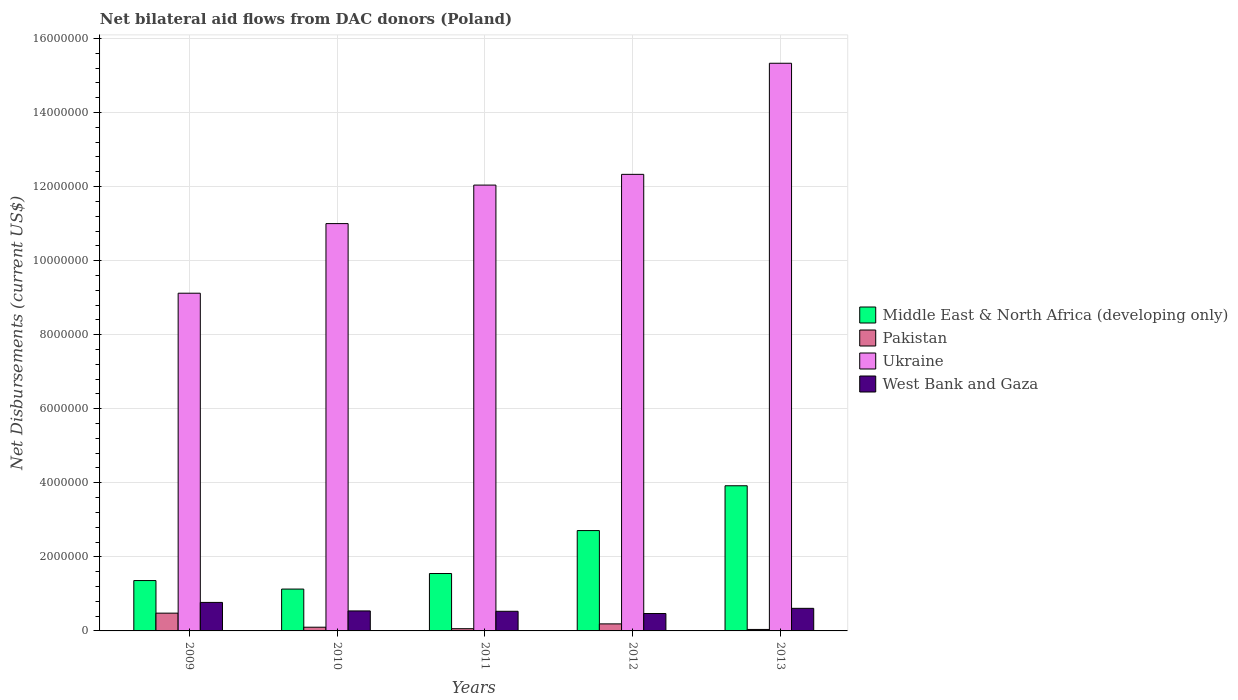Are the number of bars per tick equal to the number of legend labels?
Ensure brevity in your answer.  Yes. How many bars are there on the 1st tick from the left?
Offer a very short reply. 4. What is the net bilateral aid flows in Middle East & North Africa (developing only) in 2012?
Your answer should be very brief. 2.71e+06. Across all years, what is the maximum net bilateral aid flows in Ukraine?
Your response must be concise. 1.53e+07. Across all years, what is the minimum net bilateral aid flows in Ukraine?
Provide a short and direct response. 9.12e+06. What is the total net bilateral aid flows in Middle East & North Africa (developing only) in the graph?
Your answer should be very brief. 1.07e+07. What is the difference between the net bilateral aid flows in West Bank and Gaza in 2011 and that in 2012?
Give a very brief answer. 6.00e+04. What is the difference between the net bilateral aid flows in Middle East & North Africa (developing only) in 2009 and the net bilateral aid flows in Pakistan in 2012?
Give a very brief answer. 1.17e+06. What is the average net bilateral aid flows in Pakistan per year?
Your response must be concise. 1.74e+05. In the year 2009, what is the difference between the net bilateral aid flows in Middle East & North Africa (developing only) and net bilateral aid flows in Pakistan?
Keep it short and to the point. 8.80e+05. In how many years, is the net bilateral aid flows in Pakistan greater than 2000000 US$?
Offer a terse response. 0. What is the ratio of the net bilateral aid flows in West Bank and Gaza in 2010 to that in 2011?
Your answer should be compact. 1.02. Is the net bilateral aid flows in Middle East & North Africa (developing only) in 2011 less than that in 2013?
Offer a terse response. Yes. Is the difference between the net bilateral aid flows in Middle East & North Africa (developing only) in 2009 and 2013 greater than the difference between the net bilateral aid flows in Pakistan in 2009 and 2013?
Provide a short and direct response. No. What is the difference between the highest and the second highest net bilateral aid flows in West Bank and Gaza?
Provide a short and direct response. 1.60e+05. What is the difference between the highest and the lowest net bilateral aid flows in Ukraine?
Ensure brevity in your answer.  6.21e+06. In how many years, is the net bilateral aid flows in Ukraine greater than the average net bilateral aid flows in Ukraine taken over all years?
Make the answer very short. 3. Is the sum of the net bilateral aid flows in Middle East & North Africa (developing only) in 2010 and 2012 greater than the maximum net bilateral aid flows in West Bank and Gaza across all years?
Make the answer very short. Yes. Is it the case that in every year, the sum of the net bilateral aid flows in Middle East & North Africa (developing only) and net bilateral aid flows in West Bank and Gaza is greater than the sum of net bilateral aid flows in Pakistan and net bilateral aid flows in Ukraine?
Your answer should be compact. Yes. What does the 1st bar from the left in 2012 represents?
Your response must be concise. Middle East & North Africa (developing only). Is it the case that in every year, the sum of the net bilateral aid flows in West Bank and Gaza and net bilateral aid flows in Ukraine is greater than the net bilateral aid flows in Middle East & North Africa (developing only)?
Make the answer very short. Yes. How many bars are there?
Provide a short and direct response. 20. Are all the bars in the graph horizontal?
Give a very brief answer. No. Are the values on the major ticks of Y-axis written in scientific E-notation?
Ensure brevity in your answer.  No. What is the title of the graph?
Offer a very short reply. Net bilateral aid flows from DAC donors (Poland). What is the label or title of the Y-axis?
Keep it short and to the point. Net Disbursements (current US$). What is the Net Disbursements (current US$) in Middle East & North Africa (developing only) in 2009?
Your answer should be very brief. 1.36e+06. What is the Net Disbursements (current US$) of Pakistan in 2009?
Offer a terse response. 4.80e+05. What is the Net Disbursements (current US$) of Ukraine in 2009?
Your answer should be compact. 9.12e+06. What is the Net Disbursements (current US$) in West Bank and Gaza in 2009?
Make the answer very short. 7.70e+05. What is the Net Disbursements (current US$) in Middle East & North Africa (developing only) in 2010?
Your answer should be compact. 1.13e+06. What is the Net Disbursements (current US$) of Pakistan in 2010?
Provide a succinct answer. 1.00e+05. What is the Net Disbursements (current US$) in Ukraine in 2010?
Your answer should be compact. 1.10e+07. What is the Net Disbursements (current US$) of West Bank and Gaza in 2010?
Your answer should be very brief. 5.40e+05. What is the Net Disbursements (current US$) of Middle East & North Africa (developing only) in 2011?
Ensure brevity in your answer.  1.55e+06. What is the Net Disbursements (current US$) in Pakistan in 2011?
Make the answer very short. 6.00e+04. What is the Net Disbursements (current US$) in Ukraine in 2011?
Keep it short and to the point. 1.20e+07. What is the Net Disbursements (current US$) of West Bank and Gaza in 2011?
Keep it short and to the point. 5.30e+05. What is the Net Disbursements (current US$) in Middle East & North Africa (developing only) in 2012?
Give a very brief answer. 2.71e+06. What is the Net Disbursements (current US$) of Ukraine in 2012?
Your response must be concise. 1.23e+07. What is the Net Disbursements (current US$) of Middle East & North Africa (developing only) in 2013?
Your response must be concise. 3.92e+06. What is the Net Disbursements (current US$) of Pakistan in 2013?
Your response must be concise. 4.00e+04. What is the Net Disbursements (current US$) of Ukraine in 2013?
Provide a short and direct response. 1.53e+07. Across all years, what is the maximum Net Disbursements (current US$) of Middle East & North Africa (developing only)?
Your answer should be compact. 3.92e+06. Across all years, what is the maximum Net Disbursements (current US$) in Pakistan?
Offer a very short reply. 4.80e+05. Across all years, what is the maximum Net Disbursements (current US$) in Ukraine?
Give a very brief answer. 1.53e+07. Across all years, what is the maximum Net Disbursements (current US$) of West Bank and Gaza?
Keep it short and to the point. 7.70e+05. Across all years, what is the minimum Net Disbursements (current US$) in Middle East & North Africa (developing only)?
Make the answer very short. 1.13e+06. Across all years, what is the minimum Net Disbursements (current US$) of Pakistan?
Your response must be concise. 4.00e+04. Across all years, what is the minimum Net Disbursements (current US$) in Ukraine?
Your answer should be compact. 9.12e+06. What is the total Net Disbursements (current US$) in Middle East & North Africa (developing only) in the graph?
Ensure brevity in your answer.  1.07e+07. What is the total Net Disbursements (current US$) of Pakistan in the graph?
Give a very brief answer. 8.70e+05. What is the total Net Disbursements (current US$) in Ukraine in the graph?
Your answer should be compact. 5.98e+07. What is the total Net Disbursements (current US$) in West Bank and Gaza in the graph?
Offer a very short reply. 2.92e+06. What is the difference between the Net Disbursements (current US$) of Pakistan in 2009 and that in 2010?
Ensure brevity in your answer.  3.80e+05. What is the difference between the Net Disbursements (current US$) of Ukraine in 2009 and that in 2010?
Offer a terse response. -1.88e+06. What is the difference between the Net Disbursements (current US$) of Middle East & North Africa (developing only) in 2009 and that in 2011?
Your response must be concise. -1.90e+05. What is the difference between the Net Disbursements (current US$) in Pakistan in 2009 and that in 2011?
Your answer should be very brief. 4.20e+05. What is the difference between the Net Disbursements (current US$) in Ukraine in 2009 and that in 2011?
Offer a terse response. -2.92e+06. What is the difference between the Net Disbursements (current US$) of Middle East & North Africa (developing only) in 2009 and that in 2012?
Your answer should be compact. -1.35e+06. What is the difference between the Net Disbursements (current US$) of Pakistan in 2009 and that in 2012?
Offer a very short reply. 2.90e+05. What is the difference between the Net Disbursements (current US$) in Ukraine in 2009 and that in 2012?
Offer a terse response. -3.21e+06. What is the difference between the Net Disbursements (current US$) of Middle East & North Africa (developing only) in 2009 and that in 2013?
Keep it short and to the point. -2.56e+06. What is the difference between the Net Disbursements (current US$) in Pakistan in 2009 and that in 2013?
Your answer should be very brief. 4.40e+05. What is the difference between the Net Disbursements (current US$) of Ukraine in 2009 and that in 2013?
Offer a terse response. -6.21e+06. What is the difference between the Net Disbursements (current US$) in West Bank and Gaza in 2009 and that in 2013?
Give a very brief answer. 1.60e+05. What is the difference between the Net Disbursements (current US$) of Middle East & North Africa (developing only) in 2010 and that in 2011?
Provide a short and direct response. -4.20e+05. What is the difference between the Net Disbursements (current US$) of Pakistan in 2010 and that in 2011?
Ensure brevity in your answer.  4.00e+04. What is the difference between the Net Disbursements (current US$) of Ukraine in 2010 and that in 2011?
Your response must be concise. -1.04e+06. What is the difference between the Net Disbursements (current US$) of West Bank and Gaza in 2010 and that in 2011?
Offer a very short reply. 10000. What is the difference between the Net Disbursements (current US$) of Middle East & North Africa (developing only) in 2010 and that in 2012?
Give a very brief answer. -1.58e+06. What is the difference between the Net Disbursements (current US$) of Ukraine in 2010 and that in 2012?
Offer a terse response. -1.33e+06. What is the difference between the Net Disbursements (current US$) in West Bank and Gaza in 2010 and that in 2012?
Provide a succinct answer. 7.00e+04. What is the difference between the Net Disbursements (current US$) in Middle East & North Africa (developing only) in 2010 and that in 2013?
Give a very brief answer. -2.79e+06. What is the difference between the Net Disbursements (current US$) of Ukraine in 2010 and that in 2013?
Offer a terse response. -4.33e+06. What is the difference between the Net Disbursements (current US$) of West Bank and Gaza in 2010 and that in 2013?
Keep it short and to the point. -7.00e+04. What is the difference between the Net Disbursements (current US$) of Middle East & North Africa (developing only) in 2011 and that in 2012?
Your answer should be compact. -1.16e+06. What is the difference between the Net Disbursements (current US$) of West Bank and Gaza in 2011 and that in 2012?
Provide a succinct answer. 6.00e+04. What is the difference between the Net Disbursements (current US$) in Middle East & North Africa (developing only) in 2011 and that in 2013?
Offer a very short reply. -2.37e+06. What is the difference between the Net Disbursements (current US$) in Ukraine in 2011 and that in 2013?
Ensure brevity in your answer.  -3.29e+06. What is the difference between the Net Disbursements (current US$) of West Bank and Gaza in 2011 and that in 2013?
Offer a terse response. -8.00e+04. What is the difference between the Net Disbursements (current US$) in Middle East & North Africa (developing only) in 2012 and that in 2013?
Your response must be concise. -1.21e+06. What is the difference between the Net Disbursements (current US$) of Ukraine in 2012 and that in 2013?
Give a very brief answer. -3.00e+06. What is the difference between the Net Disbursements (current US$) of Middle East & North Africa (developing only) in 2009 and the Net Disbursements (current US$) of Pakistan in 2010?
Provide a short and direct response. 1.26e+06. What is the difference between the Net Disbursements (current US$) of Middle East & North Africa (developing only) in 2009 and the Net Disbursements (current US$) of Ukraine in 2010?
Provide a succinct answer. -9.64e+06. What is the difference between the Net Disbursements (current US$) in Middle East & North Africa (developing only) in 2009 and the Net Disbursements (current US$) in West Bank and Gaza in 2010?
Ensure brevity in your answer.  8.20e+05. What is the difference between the Net Disbursements (current US$) in Pakistan in 2009 and the Net Disbursements (current US$) in Ukraine in 2010?
Offer a very short reply. -1.05e+07. What is the difference between the Net Disbursements (current US$) of Ukraine in 2009 and the Net Disbursements (current US$) of West Bank and Gaza in 2010?
Your answer should be compact. 8.58e+06. What is the difference between the Net Disbursements (current US$) in Middle East & North Africa (developing only) in 2009 and the Net Disbursements (current US$) in Pakistan in 2011?
Offer a terse response. 1.30e+06. What is the difference between the Net Disbursements (current US$) of Middle East & North Africa (developing only) in 2009 and the Net Disbursements (current US$) of Ukraine in 2011?
Your answer should be very brief. -1.07e+07. What is the difference between the Net Disbursements (current US$) in Middle East & North Africa (developing only) in 2009 and the Net Disbursements (current US$) in West Bank and Gaza in 2011?
Keep it short and to the point. 8.30e+05. What is the difference between the Net Disbursements (current US$) in Pakistan in 2009 and the Net Disbursements (current US$) in Ukraine in 2011?
Make the answer very short. -1.16e+07. What is the difference between the Net Disbursements (current US$) of Pakistan in 2009 and the Net Disbursements (current US$) of West Bank and Gaza in 2011?
Your answer should be very brief. -5.00e+04. What is the difference between the Net Disbursements (current US$) of Ukraine in 2009 and the Net Disbursements (current US$) of West Bank and Gaza in 2011?
Your answer should be very brief. 8.59e+06. What is the difference between the Net Disbursements (current US$) in Middle East & North Africa (developing only) in 2009 and the Net Disbursements (current US$) in Pakistan in 2012?
Ensure brevity in your answer.  1.17e+06. What is the difference between the Net Disbursements (current US$) in Middle East & North Africa (developing only) in 2009 and the Net Disbursements (current US$) in Ukraine in 2012?
Offer a very short reply. -1.10e+07. What is the difference between the Net Disbursements (current US$) in Middle East & North Africa (developing only) in 2009 and the Net Disbursements (current US$) in West Bank and Gaza in 2012?
Provide a short and direct response. 8.90e+05. What is the difference between the Net Disbursements (current US$) of Pakistan in 2009 and the Net Disbursements (current US$) of Ukraine in 2012?
Offer a terse response. -1.18e+07. What is the difference between the Net Disbursements (current US$) of Pakistan in 2009 and the Net Disbursements (current US$) of West Bank and Gaza in 2012?
Your answer should be very brief. 10000. What is the difference between the Net Disbursements (current US$) in Ukraine in 2009 and the Net Disbursements (current US$) in West Bank and Gaza in 2012?
Keep it short and to the point. 8.65e+06. What is the difference between the Net Disbursements (current US$) in Middle East & North Africa (developing only) in 2009 and the Net Disbursements (current US$) in Pakistan in 2013?
Your answer should be very brief. 1.32e+06. What is the difference between the Net Disbursements (current US$) in Middle East & North Africa (developing only) in 2009 and the Net Disbursements (current US$) in Ukraine in 2013?
Offer a very short reply. -1.40e+07. What is the difference between the Net Disbursements (current US$) of Middle East & North Africa (developing only) in 2009 and the Net Disbursements (current US$) of West Bank and Gaza in 2013?
Give a very brief answer. 7.50e+05. What is the difference between the Net Disbursements (current US$) in Pakistan in 2009 and the Net Disbursements (current US$) in Ukraine in 2013?
Provide a succinct answer. -1.48e+07. What is the difference between the Net Disbursements (current US$) of Ukraine in 2009 and the Net Disbursements (current US$) of West Bank and Gaza in 2013?
Provide a short and direct response. 8.51e+06. What is the difference between the Net Disbursements (current US$) of Middle East & North Africa (developing only) in 2010 and the Net Disbursements (current US$) of Pakistan in 2011?
Your answer should be very brief. 1.07e+06. What is the difference between the Net Disbursements (current US$) of Middle East & North Africa (developing only) in 2010 and the Net Disbursements (current US$) of Ukraine in 2011?
Provide a short and direct response. -1.09e+07. What is the difference between the Net Disbursements (current US$) of Pakistan in 2010 and the Net Disbursements (current US$) of Ukraine in 2011?
Provide a succinct answer. -1.19e+07. What is the difference between the Net Disbursements (current US$) of Pakistan in 2010 and the Net Disbursements (current US$) of West Bank and Gaza in 2011?
Give a very brief answer. -4.30e+05. What is the difference between the Net Disbursements (current US$) in Ukraine in 2010 and the Net Disbursements (current US$) in West Bank and Gaza in 2011?
Provide a short and direct response. 1.05e+07. What is the difference between the Net Disbursements (current US$) of Middle East & North Africa (developing only) in 2010 and the Net Disbursements (current US$) of Pakistan in 2012?
Give a very brief answer. 9.40e+05. What is the difference between the Net Disbursements (current US$) in Middle East & North Africa (developing only) in 2010 and the Net Disbursements (current US$) in Ukraine in 2012?
Your answer should be very brief. -1.12e+07. What is the difference between the Net Disbursements (current US$) of Pakistan in 2010 and the Net Disbursements (current US$) of Ukraine in 2012?
Keep it short and to the point. -1.22e+07. What is the difference between the Net Disbursements (current US$) of Pakistan in 2010 and the Net Disbursements (current US$) of West Bank and Gaza in 2012?
Ensure brevity in your answer.  -3.70e+05. What is the difference between the Net Disbursements (current US$) in Ukraine in 2010 and the Net Disbursements (current US$) in West Bank and Gaza in 2012?
Offer a terse response. 1.05e+07. What is the difference between the Net Disbursements (current US$) in Middle East & North Africa (developing only) in 2010 and the Net Disbursements (current US$) in Pakistan in 2013?
Keep it short and to the point. 1.09e+06. What is the difference between the Net Disbursements (current US$) in Middle East & North Africa (developing only) in 2010 and the Net Disbursements (current US$) in Ukraine in 2013?
Make the answer very short. -1.42e+07. What is the difference between the Net Disbursements (current US$) in Middle East & North Africa (developing only) in 2010 and the Net Disbursements (current US$) in West Bank and Gaza in 2013?
Keep it short and to the point. 5.20e+05. What is the difference between the Net Disbursements (current US$) in Pakistan in 2010 and the Net Disbursements (current US$) in Ukraine in 2013?
Ensure brevity in your answer.  -1.52e+07. What is the difference between the Net Disbursements (current US$) of Pakistan in 2010 and the Net Disbursements (current US$) of West Bank and Gaza in 2013?
Your answer should be compact. -5.10e+05. What is the difference between the Net Disbursements (current US$) of Ukraine in 2010 and the Net Disbursements (current US$) of West Bank and Gaza in 2013?
Give a very brief answer. 1.04e+07. What is the difference between the Net Disbursements (current US$) in Middle East & North Africa (developing only) in 2011 and the Net Disbursements (current US$) in Pakistan in 2012?
Provide a short and direct response. 1.36e+06. What is the difference between the Net Disbursements (current US$) of Middle East & North Africa (developing only) in 2011 and the Net Disbursements (current US$) of Ukraine in 2012?
Offer a very short reply. -1.08e+07. What is the difference between the Net Disbursements (current US$) of Middle East & North Africa (developing only) in 2011 and the Net Disbursements (current US$) of West Bank and Gaza in 2012?
Keep it short and to the point. 1.08e+06. What is the difference between the Net Disbursements (current US$) in Pakistan in 2011 and the Net Disbursements (current US$) in Ukraine in 2012?
Make the answer very short. -1.23e+07. What is the difference between the Net Disbursements (current US$) in Pakistan in 2011 and the Net Disbursements (current US$) in West Bank and Gaza in 2012?
Keep it short and to the point. -4.10e+05. What is the difference between the Net Disbursements (current US$) of Ukraine in 2011 and the Net Disbursements (current US$) of West Bank and Gaza in 2012?
Ensure brevity in your answer.  1.16e+07. What is the difference between the Net Disbursements (current US$) in Middle East & North Africa (developing only) in 2011 and the Net Disbursements (current US$) in Pakistan in 2013?
Keep it short and to the point. 1.51e+06. What is the difference between the Net Disbursements (current US$) in Middle East & North Africa (developing only) in 2011 and the Net Disbursements (current US$) in Ukraine in 2013?
Offer a terse response. -1.38e+07. What is the difference between the Net Disbursements (current US$) in Middle East & North Africa (developing only) in 2011 and the Net Disbursements (current US$) in West Bank and Gaza in 2013?
Provide a succinct answer. 9.40e+05. What is the difference between the Net Disbursements (current US$) of Pakistan in 2011 and the Net Disbursements (current US$) of Ukraine in 2013?
Keep it short and to the point. -1.53e+07. What is the difference between the Net Disbursements (current US$) in Pakistan in 2011 and the Net Disbursements (current US$) in West Bank and Gaza in 2013?
Ensure brevity in your answer.  -5.50e+05. What is the difference between the Net Disbursements (current US$) of Ukraine in 2011 and the Net Disbursements (current US$) of West Bank and Gaza in 2013?
Make the answer very short. 1.14e+07. What is the difference between the Net Disbursements (current US$) in Middle East & North Africa (developing only) in 2012 and the Net Disbursements (current US$) in Pakistan in 2013?
Keep it short and to the point. 2.67e+06. What is the difference between the Net Disbursements (current US$) of Middle East & North Africa (developing only) in 2012 and the Net Disbursements (current US$) of Ukraine in 2013?
Offer a very short reply. -1.26e+07. What is the difference between the Net Disbursements (current US$) of Middle East & North Africa (developing only) in 2012 and the Net Disbursements (current US$) of West Bank and Gaza in 2013?
Keep it short and to the point. 2.10e+06. What is the difference between the Net Disbursements (current US$) in Pakistan in 2012 and the Net Disbursements (current US$) in Ukraine in 2013?
Give a very brief answer. -1.51e+07. What is the difference between the Net Disbursements (current US$) of Pakistan in 2012 and the Net Disbursements (current US$) of West Bank and Gaza in 2013?
Your answer should be compact. -4.20e+05. What is the difference between the Net Disbursements (current US$) of Ukraine in 2012 and the Net Disbursements (current US$) of West Bank and Gaza in 2013?
Ensure brevity in your answer.  1.17e+07. What is the average Net Disbursements (current US$) of Middle East & North Africa (developing only) per year?
Provide a succinct answer. 2.13e+06. What is the average Net Disbursements (current US$) in Pakistan per year?
Make the answer very short. 1.74e+05. What is the average Net Disbursements (current US$) in Ukraine per year?
Your answer should be compact. 1.20e+07. What is the average Net Disbursements (current US$) in West Bank and Gaza per year?
Offer a very short reply. 5.84e+05. In the year 2009, what is the difference between the Net Disbursements (current US$) of Middle East & North Africa (developing only) and Net Disbursements (current US$) of Pakistan?
Make the answer very short. 8.80e+05. In the year 2009, what is the difference between the Net Disbursements (current US$) in Middle East & North Africa (developing only) and Net Disbursements (current US$) in Ukraine?
Give a very brief answer. -7.76e+06. In the year 2009, what is the difference between the Net Disbursements (current US$) of Middle East & North Africa (developing only) and Net Disbursements (current US$) of West Bank and Gaza?
Give a very brief answer. 5.90e+05. In the year 2009, what is the difference between the Net Disbursements (current US$) of Pakistan and Net Disbursements (current US$) of Ukraine?
Provide a short and direct response. -8.64e+06. In the year 2009, what is the difference between the Net Disbursements (current US$) of Ukraine and Net Disbursements (current US$) of West Bank and Gaza?
Ensure brevity in your answer.  8.35e+06. In the year 2010, what is the difference between the Net Disbursements (current US$) of Middle East & North Africa (developing only) and Net Disbursements (current US$) of Pakistan?
Provide a succinct answer. 1.03e+06. In the year 2010, what is the difference between the Net Disbursements (current US$) of Middle East & North Africa (developing only) and Net Disbursements (current US$) of Ukraine?
Provide a succinct answer. -9.87e+06. In the year 2010, what is the difference between the Net Disbursements (current US$) of Middle East & North Africa (developing only) and Net Disbursements (current US$) of West Bank and Gaza?
Provide a short and direct response. 5.90e+05. In the year 2010, what is the difference between the Net Disbursements (current US$) of Pakistan and Net Disbursements (current US$) of Ukraine?
Your answer should be very brief. -1.09e+07. In the year 2010, what is the difference between the Net Disbursements (current US$) of Pakistan and Net Disbursements (current US$) of West Bank and Gaza?
Provide a succinct answer. -4.40e+05. In the year 2010, what is the difference between the Net Disbursements (current US$) of Ukraine and Net Disbursements (current US$) of West Bank and Gaza?
Make the answer very short. 1.05e+07. In the year 2011, what is the difference between the Net Disbursements (current US$) of Middle East & North Africa (developing only) and Net Disbursements (current US$) of Pakistan?
Provide a succinct answer. 1.49e+06. In the year 2011, what is the difference between the Net Disbursements (current US$) in Middle East & North Africa (developing only) and Net Disbursements (current US$) in Ukraine?
Provide a short and direct response. -1.05e+07. In the year 2011, what is the difference between the Net Disbursements (current US$) in Middle East & North Africa (developing only) and Net Disbursements (current US$) in West Bank and Gaza?
Keep it short and to the point. 1.02e+06. In the year 2011, what is the difference between the Net Disbursements (current US$) of Pakistan and Net Disbursements (current US$) of Ukraine?
Provide a succinct answer. -1.20e+07. In the year 2011, what is the difference between the Net Disbursements (current US$) of Pakistan and Net Disbursements (current US$) of West Bank and Gaza?
Keep it short and to the point. -4.70e+05. In the year 2011, what is the difference between the Net Disbursements (current US$) in Ukraine and Net Disbursements (current US$) in West Bank and Gaza?
Give a very brief answer. 1.15e+07. In the year 2012, what is the difference between the Net Disbursements (current US$) in Middle East & North Africa (developing only) and Net Disbursements (current US$) in Pakistan?
Ensure brevity in your answer.  2.52e+06. In the year 2012, what is the difference between the Net Disbursements (current US$) in Middle East & North Africa (developing only) and Net Disbursements (current US$) in Ukraine?
Provide a short and direct response. -9.62e+06. In the year 2012, what is the difference between the Net Disbursements (current US$) in Middle East & North Africa (developing only) and Net Disbursements (current US$) in West Bank and Gaza?
Provide a succinct answer. 2.24e+06. In the year 2012, what is the difference between the Net Disbursements (current US$) of Pakistan and Net Disbursements (current US$) of Ukraine?
Offer a very short reply. -1.21e+07. In the year 2012, what is the difference between the Net Disbursements (current US$) in Pakistan and Net Disbursements (current US$) in West Bank and Gaza?
Keep it short and to the point. -2.80e+05. In the year 2012, what is the difference between the Net Disbursements (current US$) of Ukraine and Net Disbursements (current US$) of West Bank and Gaza?
Give a very brief answer. 1.19e+07. In the year 2013, what is the difference between the Net Disbursements (current US$) in Middle East & North Africa (developing only) and Net Disbursements (current US$) in Pakistan?
Keep it short and to the point. 3.88e+06. In the year 2013, what is the difference between the Net Disbursements (current US$) in Middle East & North Africa (developing only) and Net Disbursements (current US$) in Ukraine?
Your answer should be compact. -1.14e+07. In the year 2013, what is the difference between the Net Disbursements (current US$) in Middle East & North Africa (developing only) and Net Disbursements (current US$) in West Bank and Gaza?
Ensure brevity in your answer.  3.31e+06. In the year 2013, what is the difference between the Net Disbursements (current US$) in Pakistan and Net Disbursements (current US$) in Ukraine?
Give a very brief answer. -1.53e+07. In the year 2013, what is the difference between the Net Disbursements (current US$) in Pakistan and Net Disbursements (current US$) in West Bank and Gaza?
Provide a succinct answer. -5.70e+05. In the year 2013, what is the difference between the Net Disbursements (current US$) of Ukraine and Net Disbursements (current US$) of West Bank and Gaza?
Provide a succinct answer. 1.47e+07. What is the ratio of the Net Disbursements (current US$) of Middle East & North Africa (developing only) in 2009 to that in 2010?
Make the answer very short. 1.2. What is the ratio of the Net Disbursements (current US$) in Ukraine in 2009 to that in 2010?
Ensure brevity in your answer.  0.83. What is the ratio of the Net Disbursements (current US$) in West Bank and Gaza in 2009 to that in 2010?
Ensure brevity in your answer.  1.43. What is the ratio of the Net Disbursements (current US$) in Middle East & North Africa (developing only) in 2009 to that in 2011?
Make the answer very short. 0.88. What is the ratio of the Net Disbursements (current US$) of Ukraine in 2009 to that in 2011?
Offer a terse response. 0.76. What is the ratio of the Net Disbursements (current US$) of West Bank and Gaza in 2009 to that in 2011?
Offer a terse response. 1.45. What is the ratio of the Net Disbursements (current US$) of Middle East & North Africa (developing only) in 2009 to that in 2012?
Offer a very short reply. 0.5. What is the ratio of the Net Disbursements (current US$) of Pakistan in 2009 to that in 2012?
Your answer should be compact. 2.53. What is the ratio of the Net Disbursements (current US$) of Ukraine in 2009 to that in 2012?
Provide a short and direct response. 0.74. What is the ratio of the Net Disbursements (current US$) in West Bank and Gaza in 2009 to that in 2012?
Keep it short and to the point. 1.64. What is the ratio of the Net Disbursements (current US$) of Middle East & North Africa (developing only) in 2009 to that in 2013?
Your response must be concise. 0.35. What is the ratio of the Net Disbursements (current US$) in Ukraine in 2009 to that in 2013?
Provide a succinct answer. 0.59. What is the ratio of the Net Disbursements (current US$) in West Bank and Gaza in 2009 to that in 2013?
Offer a very short reply. 1.26. What is the ratio of the Net Disbursements (current US$) in Middle East & North Africa (developing only) in 2010 to that in 2011?
Ensure brevity in your answer.  0.73. What is the ratio of the Net Disbursements (current US$) in Ukraine in 2010 to that in 2011?
Offer a terse response. 0.91. What is the ratio of the Net Disbursements (current US$) of West Bank and Gaza in 2010 to that in 2011?
Offer a terse response. 1.02. What is the ratio of the Net Disbursements (current US$) in Middle East & North Africa (developing only) in 2010 to that in 2012?
Your answer should be very brief. 0.42. What is the ratio of the Net Disbursements (current US$) of Pakistan in 2010 to that in 2012?
Keep it short and to the point. 0.53. What is the ratio of the Net Disbursements (current US$) of Ukraine in 2010 to that in 2012?
Provide a succinct answer. 0.89. What is the ratio of the Net Disbursements (current US$) of West Bank and Gaza in 2010 to that in 2012?
Your response must be concise. 1.15. What is the ratio of the Net Disbursements (current US$) in Middle East & North Africa (developing only) in 2010 to that in 2013?
Offer a very short reply. 0.29. What is the ratio of the Net Disbursements (current US$) in Pakistan in 2010 to that in 2013?
Keep it short and to the point. 2.5. What is the ratio of the Net Disbursements (current US$) in Ukraine in 2010 to that in 2013?
Offer a terse response. 0.72. What is the ratio of the Net Disbursements (current US$) in West Bank and Gaza in 2010 to that in 2013?
Offer a very short reply. 0.89. What is the ratio of the Net Disbursements (current US$) of Middle East & North Africa (developing only) in 2011 to that in 2012?
Give a very brief answer. 0.57. What is the ratio of the Net Disbursements (current US$) in Pakistan in 2011 to that in 2012?
Provide a short and direct response. 0.32. What is the ratio of the Net Disbursements (current US$) of Ukraine in 2011 to that in 2012?
Provide a short and direct response. 0.98. What is the ratio of the Net Disbursements (current US$) of West Bank and Gaza in 2011 to that in 2012?
Give a very brief answer. 1.13. What is the ratio of the Net Disbursements (current US$) in Middle East & North Africa (developing only) in 2011 to that in 2013?
Your response must be concise. 0.4. What is the ratio of the Net Disbursements (current US$) of Pakistan in 2011 to that in 2013?
Keep it short and to the point. 1.5. What is the ratio of the Net Disbursements (current US$) in Ukraine in 2011 to that in 2013?
Your answer should be compact. 0.79. What is the ratio of the Net Disbursements (current US$) in West Bank and Gaza in 2011 to that in 2013?
Offer a terse response. 0.87. What is the ratio of the Net Disbursements (current US$) of Middle East & North Africa (developing only) in 2012 to that in 2013?
Make the answer very short. 0.69. What is the ratio of the Net Disbursements (current US$) of Pakistan in 2012 to that in 2013?
Give a very brief answer. 4.75. What is the ratio of the Net Disbursements (current US$) of Ukraine in 2012 to that in 2013?
Ensure brevity in your answer.  0.8. What is the ratio of the Net Disbursements (current US$) of West Bank and Gaza in 2012 to that in 2013?
Ensure brevity in your answer.  0.77. What is the difference between the highest and the second highest Net Disbursements (current US$) of Middle East & North Africa (developing only)?
Your response must be concise. 1.21e+06. What is the difference between the highest and the second highest Net Disbursements (current US$) of Pakistan?
Offer a very short reply. 2.90e+05. What is the difference between the highest and the second highest Net Disbursements (current US$) in Ukraine?
Your response must be concise. 3.00e+06. What is the difference between the highest and the lowest Net Disbursements (current US$) in Middle East & North Africa (developing only)?
Keep it short and to the point. 2.79e+06. What is the difference between the highest and the lowest Net Disbursements (current US$) in Pakistan?
Provide a short and direct response. 4.40e+05. What is the difference between the highest and the lowest Net Disbursements (current US$) in Ukraine?
Ensure brevity in your answer.  6.21e+06. 